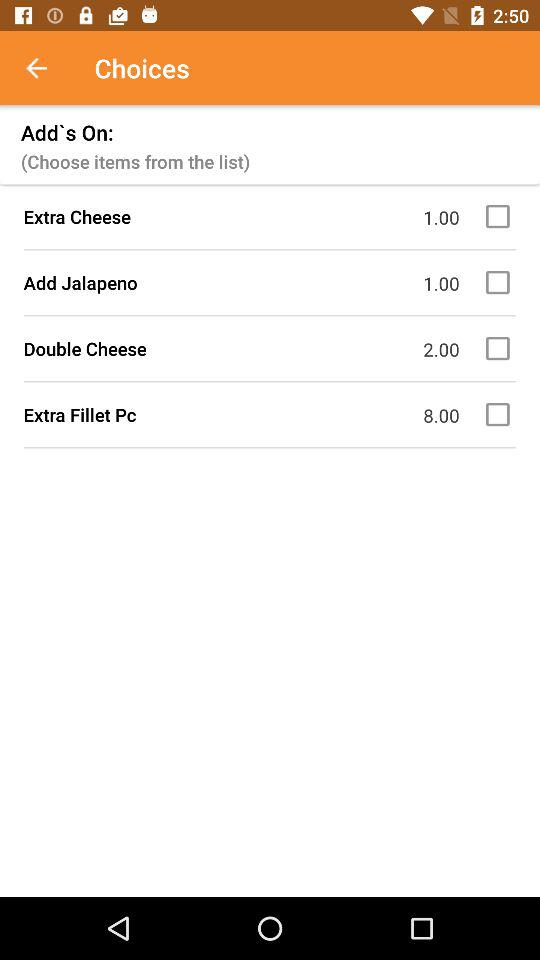What is the price for "Extra Cheese"? The price is 1.00. 